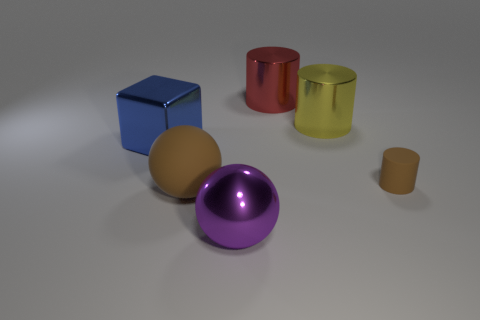Can you describe the size relationship between the objects in the image? Certainly! The image features a collection of objects with varying sizes. The blue cube and the red cylinder appear to be the largest objects. The brown ball, while smaller than the largest objects, still has a substantial size. The purple sphere is smaller than the brown ball but larger than the smallest objects in the scene, which are the tiny brown matte cylinder and what appears to be a small yellow cylinder. These small objects are diminutive in comparison to the rest. 